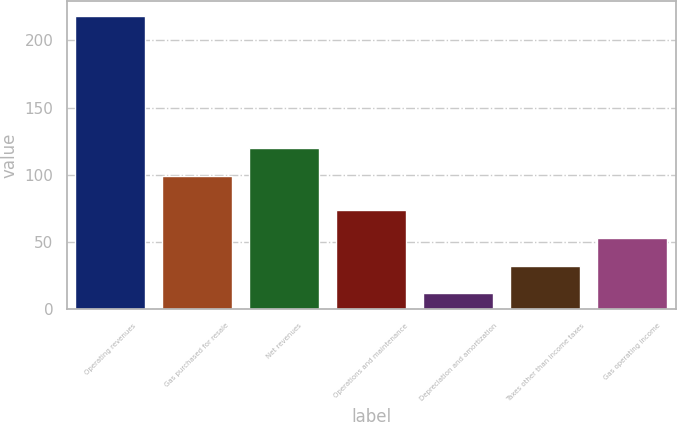<chart> <loc_0><loc_0><loc_500><loc_500><bar_chart><fcel>Operating revenues<fcel>Gas purchased for resale<fcel>Net revenues<fcel>Operations and maintenance<fcel>Depreciation and amortization<fcel>Taxes other than income taxes<fcel>Gas operating income<nl><fcel>218<fcel>99<fcel>119.6<fcel>73.8<fcel>12<fcel>32.6<fcel>53.2<nl></chart> 